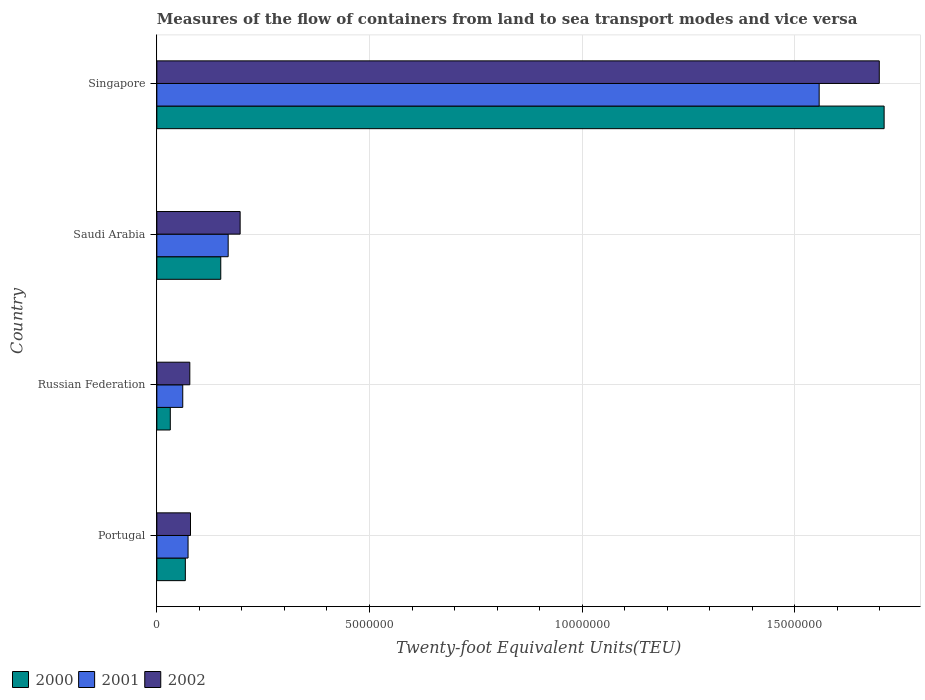Are the number of bars on each tick of the Y-axis equal?
Provide a short and direct response. Yes. How many bars are there on the 3rd tick from the top?
Make the answer very short. 3. What is the label of the 2nd group of bars from the top?
Keep it short and to the point. Saudi Arabia. In how many cases, is the number of bars for a given country not equal to the number of legend labels?
Ensure brevity in your answer.  0. What is the container port traffic in 2000 in Russian Federation?
Your response must be concise. 3.16e+05. Across all countries, what is the maximum container port traffic in 2000?
Ensure brevity in your answer.  1.71e+07. Across all countries, what is the minimum container port traffic in 2000?
Provide a short and direct response. 3.16e+05. In which country was the container port traffic in 2001 maximum?
Ensure brevity in your answer.  Singapore. In which country was the container port traffic in 2002 minimum?
Give a very brief answer. Russian Federation. What is the total container port traffic in 2002 in the graph?
Make the answer very short. 2.05e+07. What is the difference between the container port traffic in 2002 in Portugal and that in Singapore?
Give a very brief answer. -1.62e+07. What is the difference between the container port traffic in 2002 in Russian Federation and the container port traffic in 2000 in Singapore?
Your response must be concise. -1.63e+07. What is the average container port traffic in 2002 per country?
Provide a short and direct response. 5.13e+06. What is the difference between the container port traffic in 2002 and container port traffic in 2000 in Singapore?
Your answer should be compact. -1.14e+05. In how many countries, is the container port traffic in 2002 greater than 13000000 TEU?
Your response must be concise. 1. What is the ratio of the container port traffic in 2002 in Saudi Arabia to that in Singapore?
Offer a terse response. 0.12. What is the difference between the highest and the second highest container port traffic in 2000?
Provide a short and direct response. 1.56e+07. What is the difference between the highest and the lowest container port traffic in 2001?
Offer a very short reply. 1.50e+07. In how many countries, is the container port traffic in 2002 greater than the average container port traffic in 2002 taken over all countries?
Your answer should be compact. 1. How many countries are there in the graph?
Give a very brief answer. 4. Does the graph contain grids?
Make the answer very short. Yes. Where does the legend appear in the graph?
Make the answer very short. Bottom left. How are the legend labels stacked?
Keep it short and to the point. Horizontal. What is the title of the graph?
Your response must be concise. Measures of the flow of containers from land to sea transport modes and vice versa. Does "1972" appear as one of the legend labels in the graph?
Offer a terse response. No. What is the label or title of the X-axis?
Give a very brief answer. Twenty-foot Equivalent Units(TEU). What is the Twenty-foot Equivalent Units(TEU) of 2000 in Portugal?
Provide a short and direct response. 6.70e+05. What is the Twenty-foot Equivalent Units(TEU) in 2001 in Portugal?
Make the answer very short. 7.34e+05. What is the Twenty-foot Equivalent Units(TEU) of 2002 in Portugal?
Offer a terse response. 7.91e+05. What is the Twenty-foot Equivalent Units(TEU) of 2000 in Russian Federation?
Your answer should be compact. 3.16e+05. What is the Twenty-foot Equivalent Units(TEU) of 2001 in Russian Federation?
Offer a terse response. 6.09e+05. What is the Twenty-foot Equivalent Units(TEU) of 2002 in Russian Federation?
Your answer should be compact. 7.75e+05. What is the Twenty-foot Equivalent Units(TEU) of 2000 in Saudi Arabia?
Provide a short and direct response. 1.50e+06. What is the Twenty-foot Equivalent Units(TEU) in 2001 in Saudi Arabia?
Your response must be concise. 1.68e+06. What is the Twenty-foot Equivalent Units(TEU) of 2002 in Saudi Arabia?
Offer a terse response. 1.96e+06. What is the Twenty-foot Equivalent Units(TEU) in 2000 in Singapore?
Provide a short and direct response. 1.71e+07. What is the Twenty-foot Equivalent Units(TEU) in 2001 in Singapore?
Offer a very short reply. 1.56e+07. What is the Twenty-foot Equivalent Units(TEU) of 2002 in Singapore?
Provide a short and direct response. 1.70e+07. Across all countries, what is the maximum Twenty-foot Equivalent Units(TEU) in 2000?
Provide a short and direct response. 1.71e+07. Across all countries, what is the maximum Twenty-foot Equivalent Units(TEU) in 2001?
Offer a very short reply. 1.56e+07. Across all countries, what is the maximum Twenty-foot Equivalent Units(TEU) in 2002?
Offer a very short reply. 1.70e+07. Across all countries, what is the minimum Twenty-foot Equivalent Units(TEU) in 2000?
Your response must be concise. 3.16e+05. Across all countries, what is the minimum Twenty-foot Equivalent Units(TEU) in 2001?
Your answer should be compact. 6.09e+05. Across all countries, what is the minimum Twenty-foot Equivalent Units(TEU) of 2002?
Offer a terse response. 7.75e+05. What is the total Twenty-foot Equivalent Units(TEU) in 2000 in the graph?
Offer a very short reply. 1.96e+07. What is the total Twenty-foot Equivalent Units(TEU) of 2001 in the graph?
Offer a terse response. 1.86e+07. What is the total Twenty-foot Equivalent Units(TEU) of 2002 in the graph?
Offer a very short reply. 2.05e+07. What is the difference between the Twenty-foot Equivalent Units(TEU) in 2000 in Portugal and that in Russian Federation?
Give a very brief answer. 3.54e+05. What is the difference between the Twenty-foot Equivalent Units(TEU) of 2001 in Portugal and that in Russian Federation?
Make the answer very short. 1.25e+05. What is the difference between the Twenty-foot Equivalent Units(TEU) in 2002 in Portugal and that in Russian Federation?
Offer a very short reply. 1.63e+04. What is the difference between the Twenty-foot Equivalent Units(TEU) in 2000 in Portugal and that in Saudi Arabia?
Offer a very short reply. -8.33e+05. What is the difference between the Twenty-foot Equivalent Units(TEU) in 2001 in Portugal and that in Saudi Arabia?
Offer a terse response. -9.43e+05. What is the difference between the Twenty-foot Equivalent Units(TEU) in 2002 in Portugal and that in Saudi Arabia?
Provide a short and direct response. -1.17e+06. What is the difference between the Twenty-foot Equivalent Units(TEU) of 2000 in Portugal and that in Singapore?
Give a very brief answer. -1.64e+07. What is the difference between the Twenty-foot Equivalent Units(TEU) in 2001 in Portugal and that in Singapore?
Make the answer very short. -1.48e+07. What is the difference between the Twenty-foot Equivalent Units(TEU) of 2002 in Portugal and that in Singapore?
Provide a short and direct response. -1.62e+07. What is the difference between the Twenty-foot Equivalent Units(TEU) in 2000 in Russian Federation and that in Saudi Arabia?
Offer a terse response. -1.19e+06. What is the difference between the Twenty-foot Equivalent Units(TEU) in 2001 in Russian Federation and that in Saudi Arabia?
Ensure brevity in your answer.  -1.07e+06. What is the difference between the Twenty-foot Equivalent Units(TEU) in 2002 in Russian Federation and that in Saudi Arabia?
Provide a short and direct response. -1.18e+06. What is the difference between the Twenty-foot Equivalent Units(TEU) in 2000 in Russian Federation and that in Singapore?
Give a very brief answer. -1.68e+07. What is the difference between the Twenty-foot Equivalent Units(TEU) in 2001 in Russian Federation and that in Singapore?
Provide a short and direct response. -1.50e+07. What is the difference between the Twenty-foot Equivalent Units(TEU) of 2002 in Russian Federation and that in Singapore?
Give a very brief answer. -1.62e+07. What is the difference between the Twenty-foot Equivalent Units(TEU) of 2000 in Saudi Arabia and that in Singapore?
Your answer should be very brief. -1.56e+07. What is the difference between the Twenty-foot Equivalent Units(TEU) in 2001 in Saudi Arabia and that in Singapore?
Your response must be concise. -1.39e+07. What is the difference between the Twenty-foot Equivalent Units(TEU) of 2002 in Saudi Arabia and that in Singapore?
Offer a terse response. -1.50e+07. What is the difference between the Twenty-foot Equivalent Units(TEU) in 2000 in Portugal and the Twenty-foot Equivalent Units(TEU) in 2001 in Russian Federation?
Provide a short and direct response. 6.09e+04. What is the difference between the Twenty-foot Equivalent Units(TEU) in 2000 in Portugal and the Twenty-foot Equivalent Units(TEU) in 2002 in Russian Federation?
Keep it short and to the point. -1.05e+05. What is the difference between the Twenty-foot Equivalent Units(TEU) of 2001 in Portugal and the Twenty-foot Equivalent Units(TEU) of 2002 in Russian Federation?
Offer a terse response. -4.10e+04. What is the difference between the Twenty-foot Equivalent Units(TEU) in 2000 in Portugal and the Twenty-foot Equivalent Units(TEU) in 2001 in Saudi Arabia?
Keep it short and to the point. -1.01e+06. What is the difference between the Twenty-foot Equivalent Units(TEU) in 2000 in Portugal and the Twenty-foot Equivalent Units(TEU) in 2002 in Saudi Arabia?
Provide a short and direct response. -1.29e+06. What is the difference between the Twenty-foot Equivalent Units(TEU) of 2001 in Portugal and the Twenty-foot Equivalent Units(TEU) of 2002 in Saudi Arabia?
Offer a very short reply. -1.22e+06. What is the difference between the Twenty-foot Equivalent Units(TEU) of 2000 in Portugal and the Twenty-foot Equivalent Units(TEU) of 2001 in Singapore?
Your answer should be very brief. -1.49e+07. What is the difference between the Twenty-foot Equivalent Units(TEU) in 2000 in Portugal and the Twenty-foot Equivalent Units(TEU) in 2002 in Singapore?
Your response must be concise. -1.63e+07. What is the difference between the Twenty-foot Equivalent Units(TEU) of 2001 in Portugal and the Twenty-foot Equivalent Units(TEU) of 2002 in Singapore?
Ensure brevity in your answer.  -1.63e+07. What is the difference between the Twenty-foot Equivalent Units(TEU) in 2000 in Russian Federation and the Twenty-foot Equivalent Units(TEU) in 2001 in Saudi Arabia?
Give a very brief answer. -1.36e+06. What is the difference between the Twenty-foot Equivalent Units(TEU) in 2000 in Russian Federation and the Twenty-foot Equivalent Units(TEU) in 2002 in Saudi Arabia?
Offer a terse response. -1.64e+06. What is the difference between the Twenty-foot Equivalent Units(TEU) of 2001 in Russian Federation and the Twenty-foot Equivalent Units(TEU) of 2002 in Saudi Arabia?
Your response must be concise. -1.35e+06. What is the difference between the Twenty-foot Equivalent Units(TEU) in 2000 in Russian Federation and the Twenty-foot Equivalent Units(TEU) in 2001 in Singapore?
Offer a very short reply. -1.53e+07. What is the difference between the Twenty-foot Equivalent Units(TEU) in 2000 in Russian Federation and the Twenty-foot Equivalent Units(TEU) in 2002 in Singapore?
Give a very brief answer. -1.67e+07. What is the difference between the Twenty-foot Equivalent Units(TEU) of 2001 in Russian Federation and the Twenty-foot Equivalent Units(TEU) of 2002 in Singapore?
Provide a short and direct response. -1.64e+07. What is the difference between the Twenty-foot Equivalent Units(TEU) of 2000 in Saudi Arabia and the Twenty-foot Equivalent Units(TEU) of 2001 in Singapore?
Offer a terse response. -1.41e+07. What is the difference between the Twenty-foot Equivalent Units(TEU) in 2000 in Saudi Arabia and the Twenty-foot Equivalent Units(TEU) in 2002 in Singapore?
Your answer should be very brief. -1.55e+07. What is the difference between the Twenty-foot Equivalent Units(TEU) of 2001 in Saudi Arabia and the Twenty-foot Equivalent Units(TEU) of 2002 in Singapore?
Your answer should be very brief. -1.53e+07. What is the average Twenty-foot Equivalent Units(TEU) of 2000 per country?
Your answer should be very brief. 4.90e+06. What is the average Twenty-foot Equivalent Units(TEU) in 2001 per country?
Keep it short and to the point. 4.65e+06. What is the average Twenty-foot Equivalent Units(TEU) in 2002 per country?
Make the answer very short. 5.13e+06. What is the difference between the Twenty-foot Equivalent Units(TEU) of 2000 and Twenty-foot Equivalent Units(TEU) of 2001 in Portugal?
Provide a succinct answer. -6.40e+04. What is the difference between the Twenty-foot Equivalent Units(TEU) in 2000 and Twenty-foot Equivalent Units(TEU) in 2002 in Portugal?
Make the answer very short. -1.21e+05. What is the difference between the Twenty-foot Equivalent Units(TEU) in 2001 and Twenty-foot Equivalent Units(TEU) in 2002 in Portugal?
Keep it short and to the point. -5.74e+04. What is the difference between the Twenty-foot Equivalent Units(TEU) of 2000 and Twenty-foot Equivalent Units(TEU) of 2001 in Russian Federation?
Provide a succinct answer. -2.93e+05. What is the difference between the Twenty-foot Equivalent Units(TEU) of 2000 and Twenty-foot Equivalent Units(TEU) of 2002 in Russian Federation?
Your answer should be very brief. -4.59e+05. What is the difference between the Twenty-foot Equivalent Units(TEU) in 2001 and Twenty-foot Equivalent Units(TEU) in 2002 in Russian Federation?
Offer a terse response. -1.66e+05. What is the difference between the Twenty-foot Equivalent Units(TEU) in 2000 and Twenty-foot Equivalent Units(TEU) in 2001 in Saudi Arabia?
Your response must be concise. -1.74e+05. What is the difference between the Twenty-foot Equivalent Units(TEU) in 2000 and Twenty-foot Equivalent Units(TEU) in 2002 in Saudi Arabia?
Ensure brevity in your answer.  -4.56e+05. What is the difference between the Twenty-foot Equivalent Units(TEU) of 2001 and Twenty-foot Equivalent Units(TEU) of 2002 in Saudi Arabia?
Provide a short and direct response. -2.82e+05. What is the difference between the Twenty-foot Equivalent Units(TEU) in 2000 and Twenty-foot Equivalent Units(TEU) in 2001 in Singapore?
Provide a short and direct response. 1.53e+06. What is the difference between the Twenty-foot Equivalent Units(TEU) of 2000 and Twenty-foot Equivalent Units(TEU) of 2002 in Singapore?
Offer a terse response. 1.14e+05. What is the difference between the Twenty-foot Equivalent Units(TEU) of 2001 and Twenty-foot Equivalent Units(TEU) of 2002 in Singapore?
Your response must be concise. -1.41e+06. What is the ratio of the Twenty-foot Equivalent Units(TEU) of 2000 in Portugal to that in Russian Federation?
Offer a terse response. 2.12. What is the ratio of the Twenty-foot Equivalent Units(TEU) of 2001 in Portugal to that in Russian Federation?
Provide a succinct answer. 1.21. What is the ratio of the Twenty-foot Equivalent Units(TEU) in 2002 in Portugal to that in Russian Federation?
Offer a terse response. 1.02. What is the ratio of the Twenty-foot Equivalent Units(TEU) in 2000 in Portugal to that in Saudi Arabia?
Ensure brevity in your answer.  0.45. What is the ratio of the Twenty-foot Equivalent Units(TEU) in 2001 in Portugal to that in Saudi Arabia?
Give a very brief answer. 0.44. What is the ratio of the Twenty-foot Equivalent Units(TEU) in 2002 in Portugal to that in Saudi Arabia?
Provide a short and direct response. 0.4. What is the ratio of the Twenty-foot Equivalent Units(TEU) in 2000 in Portugal to that in Singapore?
Keep it short and to the point. 0.04. What is the ratio of the Twenty-foot Equivalent Units(TEU) in 2001 in Portugal to that in Singapore?
Offer a very short reply. 0.05. What is the ratio of the Twenty-foot Equivalent Units(TEU) of 2002 in Portugal to that in Singapore?
Your answer should be very brief. 0.05. What is the ratio of the Twenty-foot Equivalent Units(TEU) in 2000 in Russian Federation to that in Saudi Arabia?
Make the answer very short. 0.21. What is the ratio of the Twenty-foot Equivalent Units(TEU) of 2001 in Russian Federation to that in Saudi Arabia?
Keep it short and to the point. 0.36. What is the ratio of the Twenty-foot Equivalent Units(TEU) in 2002 in Russian Federation to that in Saudi Arabia?
Provide a short and direct response. 0.4. What is the ratio of the Twenty-foot Equivalent Units(TEU) of 2000 in Russian Federation to that in Singapore?
Provide a short and direct response. 0.02. What is the ratio of the Twenty-foot Equivalent Units(TEU) in 2001 in Russian Federation to that in Singapore?
Give a very brief answer. 0.04. What is the ratio of the Twenty-foot Equivalent Units(TEU) of 2002 in Russian Federation to that in Singapore?
Make the answer very short. 0.05. What is the ratio of the Twenty-foot Equivalent Units(TEU) in 2000 in Saudi Arabia to that in Singapore?
Make the answer very short. 0.09. What is the ratio of the Twenty-foot Equivalent Units(TEU) in 2001 in Saudi Arabia to that in Singapore?
Offer a terse response. 0.11. What is the ratio of the Twenty-foot Equivalent Units(TEU) of 2002 in Saudi Arabia to that in Singapore?
Give a very brief answer. 0.12. What is the difference between the highest and the second highest Twenty-foot Equivalent Units(TEU) of 2000?
Make the answer very short. 1.56e+07. What is the difference between the highest and the second highest Twenty-foot Equivalent Units(TEU) in 2001?
Give a very brief answer. 1.39e+07. What is the difference between the highest and the second highest Twenty-foot Equivalent Units(TEU) in 2002?
Keep it short and to the point. 1.50e+07. What is the difference between the highest and the lowest Twenty-foot Equivalent Units(TEU) of 2000?
Your response must be concise. 1.68e+07. What is the difference between the highest and the lowest Twenty-foot Equivalent Units(TEU) in 2001?
Your response must be concise. 1.50e+07. What is the difference between the highest and the lowest Twenty-foot Equivalent Units(TEU) of 2002?
Give a very brief answer. 1.62e+07. 